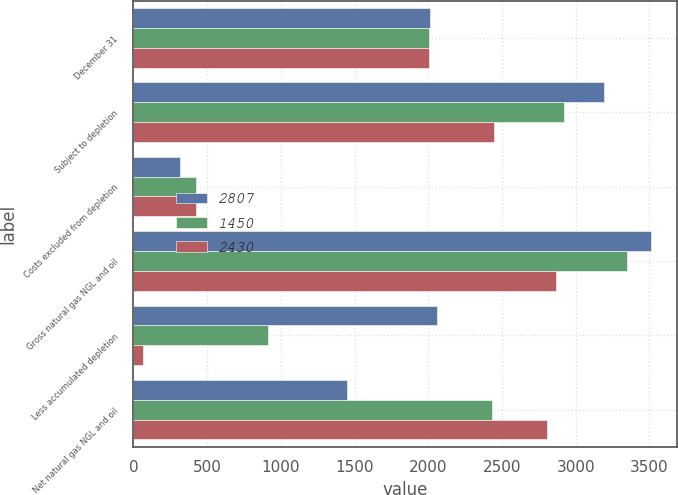Convert chart. <chart><loc_0><loc_0><loc_500><loc_500><stacked_bar_chart><ecel><fcel>December 31<fcel>Subject to depletion<fcel>Costs excluded from depletion<fcel>Gross natural gas NGL and oil<fcel>Less accumulated depletion<fcel>Net natural gas NGL and oil<nl><fcel>2807<fcel>2009<fcel>3194<fcel>317<fcel>3511<fcel>2061<fcel>1450<nl><fcel>1450<fcel>2008<fcel>2923<fcel>422<fcel>3345<fcel>915<fcel>2430<nl><fcel>2430<fcel>2007<fcel>2443<fcel>426<fcel>2869<fcel>62<fcel>2807<nl></chart> 